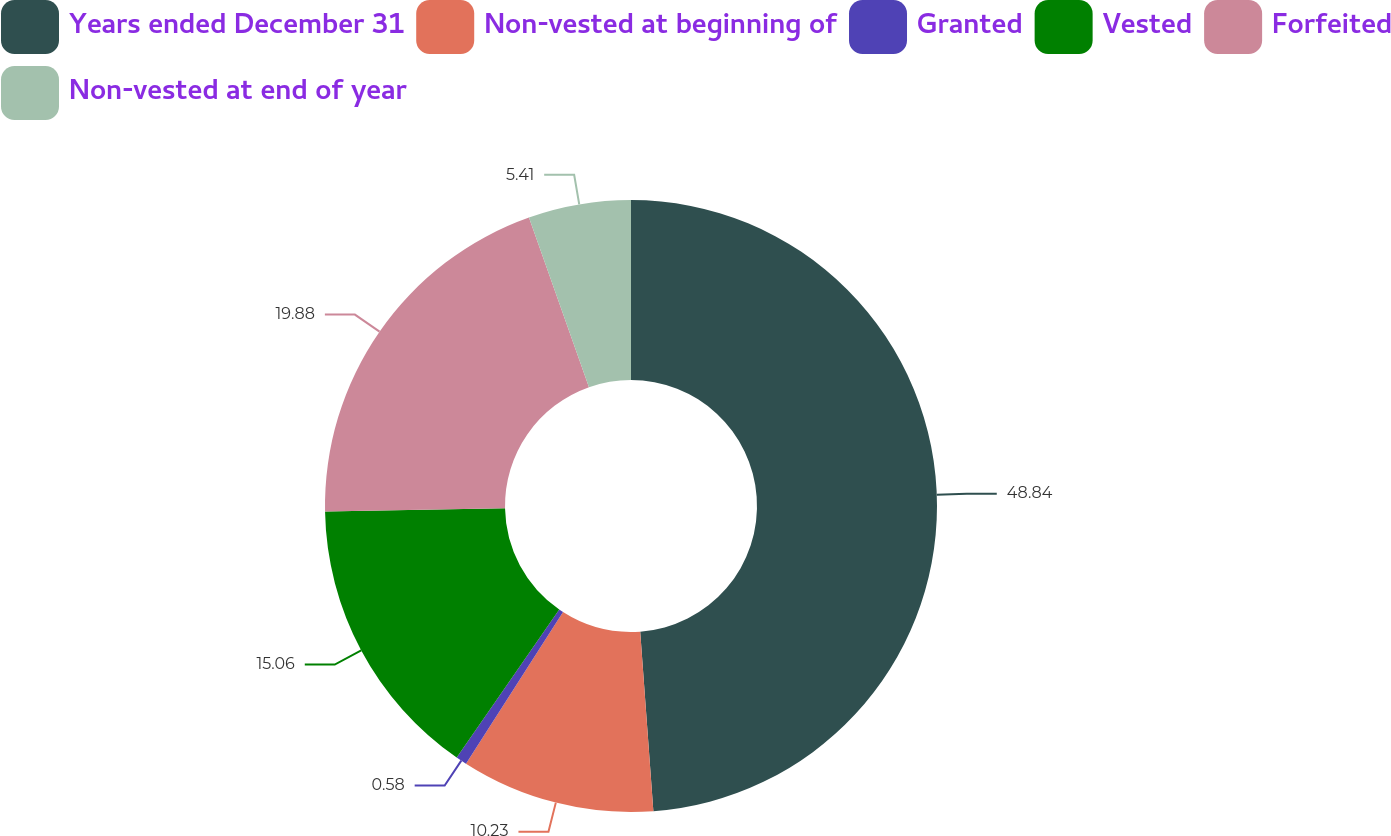Convert chart. <chart><loc_0><loc_0><loc_500><loc_500><pie_chart><fcel>Years ended December 31<fcel>Non-vested at beginning of<fcel>Granted<fcel>Vested<fcel>Forfeited<fcel>Non-vested at end of year<nl><fcel>48.83%<fcel>10.23%<fcel>0.58%<fcel>15.06%<fcel>19.88%<fcel>5.41%<nl></chart> 